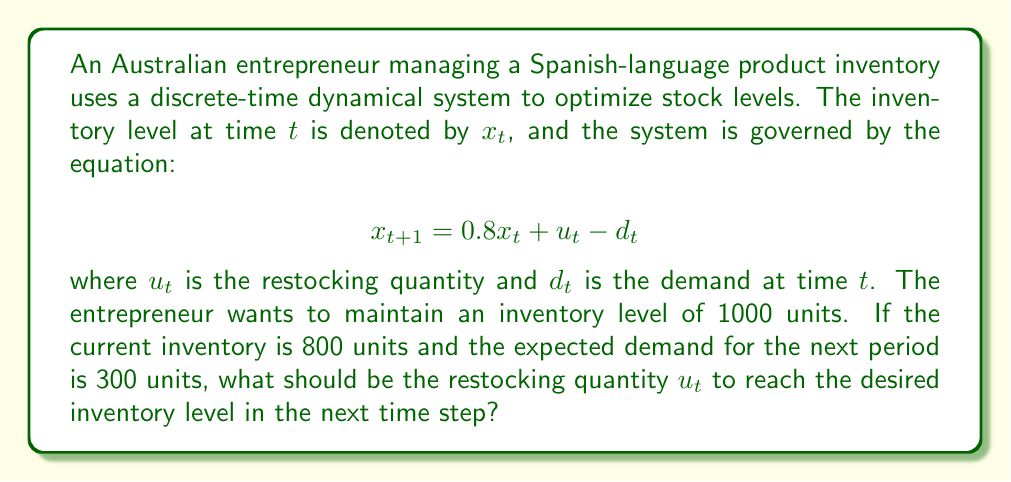Can you solve this math problem? Let's approach this step-by-step:

1) We are given the discrete-time dynamical system equation:
   $$x_{t+1} = 0.8x_t + u_t - d_t$$

2) We want to find $u_t$ such that $x_{t+1} = 1000$ (the desired inventory level).

3) We know:
   - Current inventory $x_t = 800$
   - Expected demand $d_t = 300$
   - Desired next inventory $x_{t+1} = 1000$

4) Let's substitute these values into the equation:
   $$1000 = 0.8(800) + u_t - 300$$

5) Simplify the right side:
   $$1000 = 640 + u_t - 300$$

6) Combine like terms:
   $$1000 = 340 + u_t$$

7) Subtract 340 from both sides:
   $$660 = u_t$$

Therefore, the restocking quantity $u_t$ should be 660 units to reach the desired inventory level in the next time step.
Answer: $u_t = 660$ units 